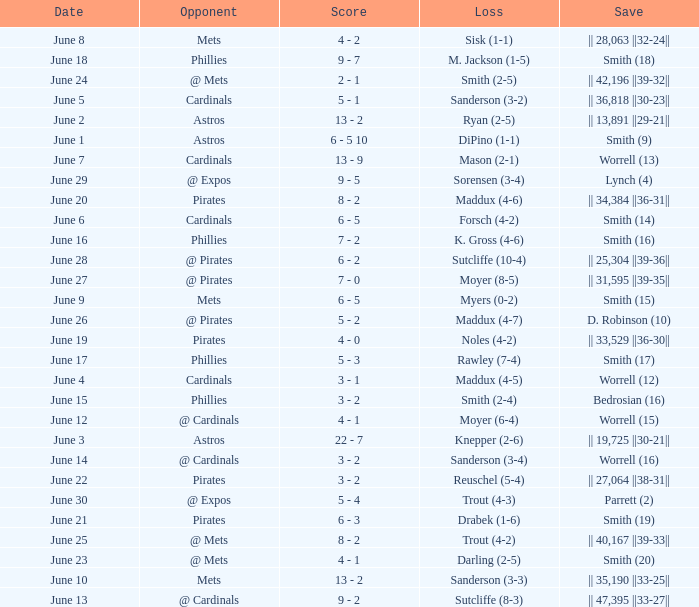What is the date for the game that included a loss of sutcliffe (10-4)? June 28. 